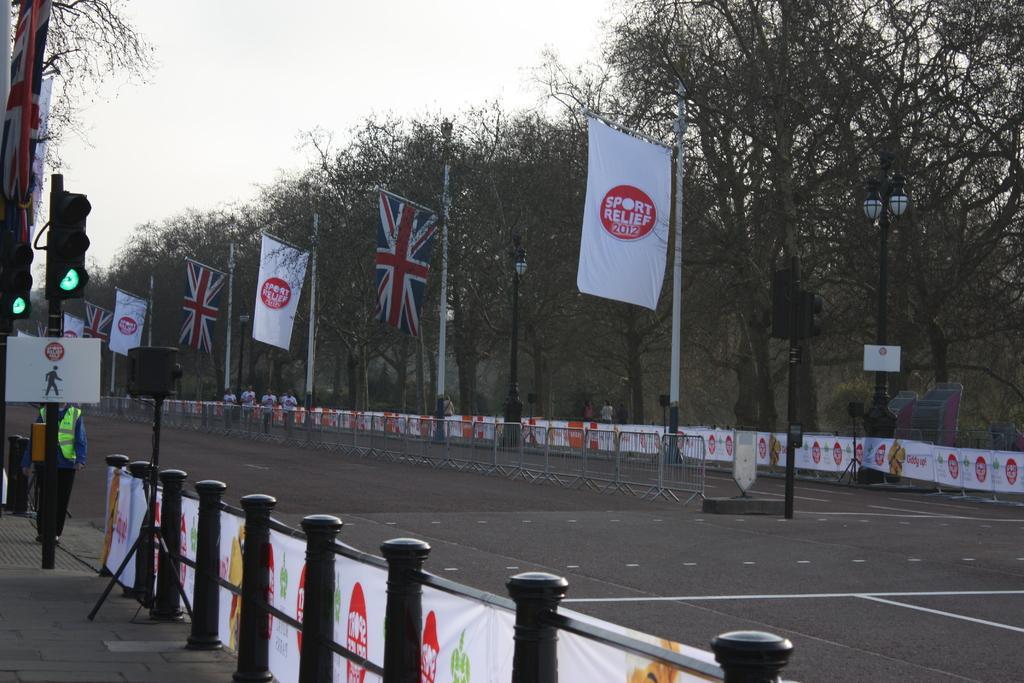Could you give a brief overview of what you see in this image? In this image there are poles on it banner is attached. Here there is a speaker on a tripod stand. In the left traffic signal and sign board , a person is standing over here. In the background there are trees, street lights, flags. In the middle of the road there is barricade. People are on the road. The sky is clear. There is green light on the traffic signal. 